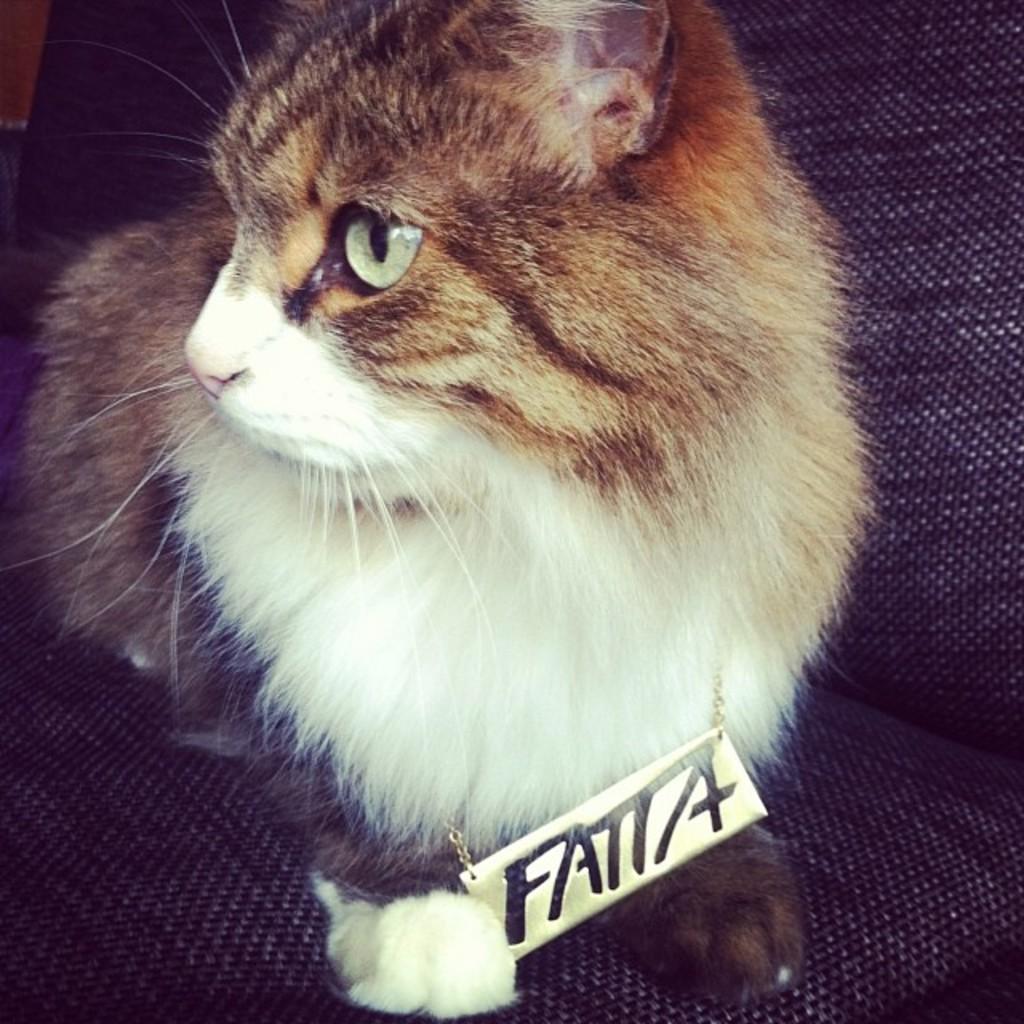In one or two sentences, can you explain what this image depicts? In the foreground of this picture, there is a cat sitting on a chair with a locket named " FATTA" in its neck. 